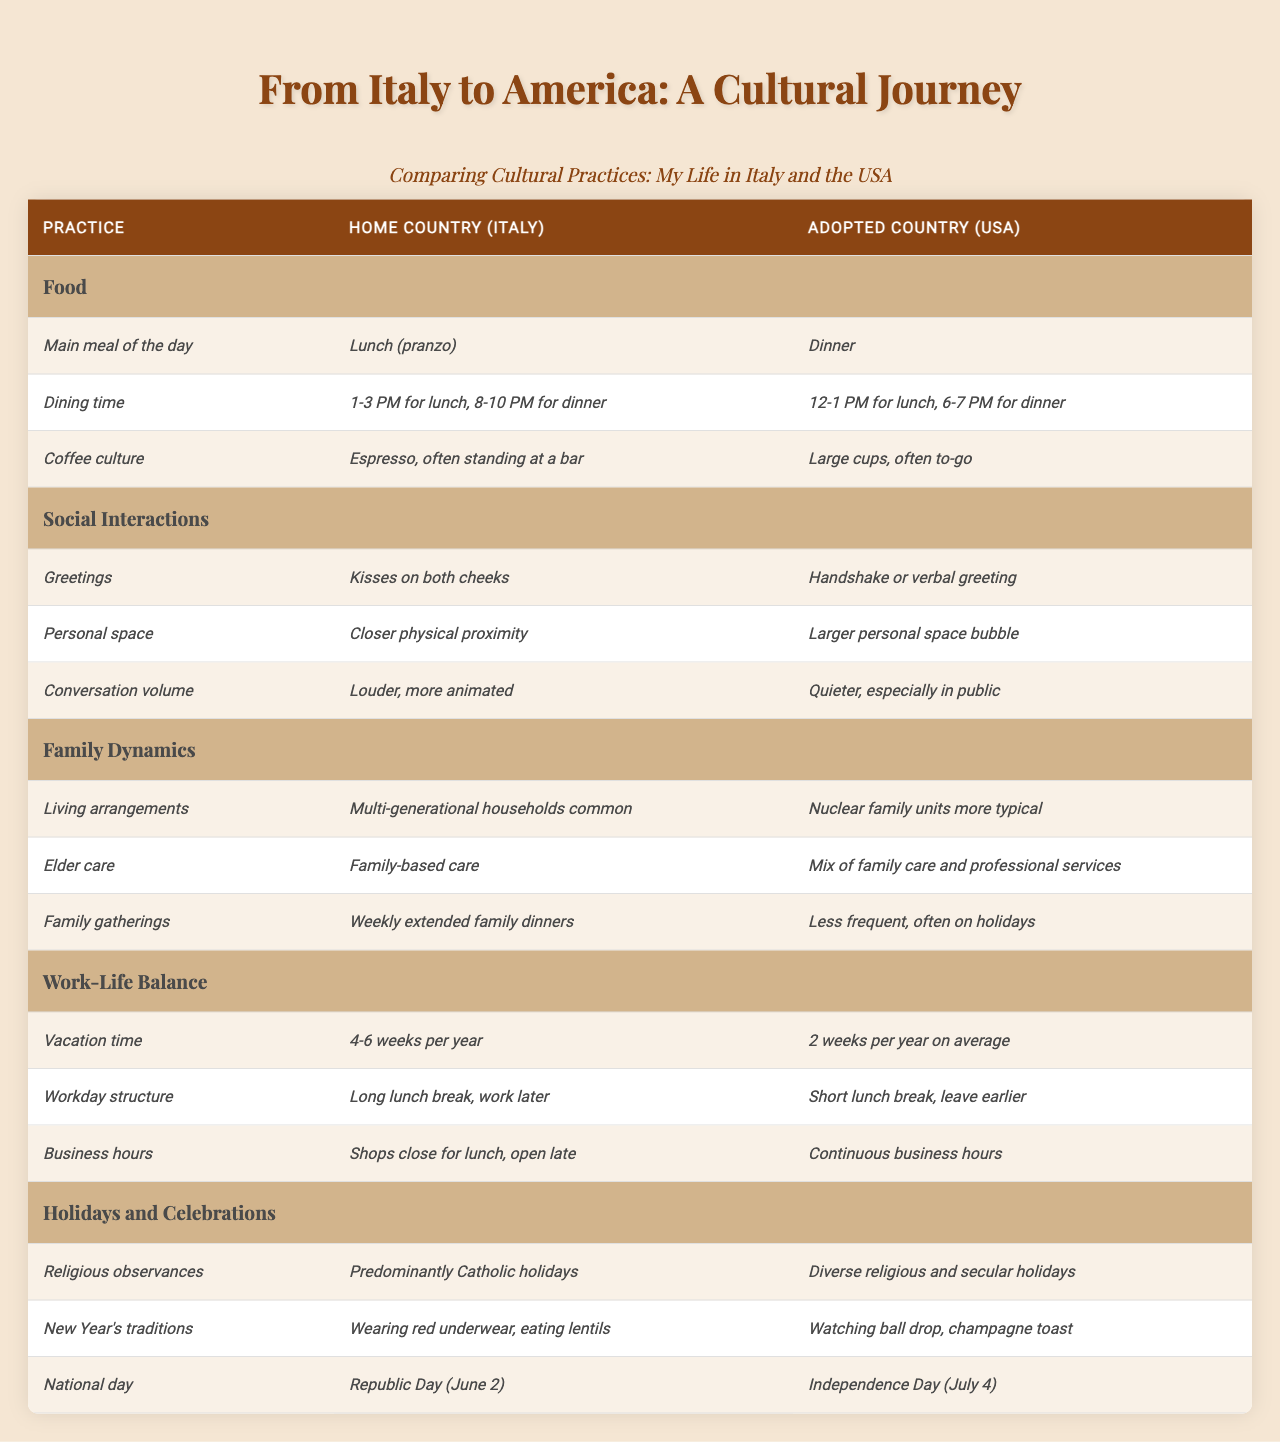What is the main meal of the day in Italy? The table indicates that in Italy, the main meal of the day is lunch (pranzo). Therefore, the information can be directly retrieved from the "Food" category under the "Main meal of the day" practice.
Answer: Lunch (pranzo) How often do families in Italy have extended family dinners compared to the USA? According to the table, Italian families have weekly extended family dinners, while such gatherings are less frequent in the USA and often occur only during holidays. This provides a clear contrast in family gathering frequency.
Answer: Weekly in Italy vs. Less frequent in the USA What is the dining time for lunch in the USA? The table specifies that in the USA, the dining time for lunch is between 12-1 PM. This is straightforwardly mentioned under the "Dining time" practice in the "Food" category.
Answer: 12-1 PM Is the coffee culture in Italy characterized by large cups and to-go options? No, the table indicates that in Italy, the coffee culture is focused on espresso, often enjoyed standing at a bar, which is different from the large cups and to-go options prevalent in the USA.
Answer: No What is the difference in vacation time between Italy and the USA? The table shows that Italians typically enjoy 4-6 weeks of vacation per year, while Americans average only 2 weeks per year. To find the difference, one would calculate the range of vacation weeks: 4 to 6 weeks in Italy compared to 2 weeks in the USA. The difference is significant.
Answer: 2-4 weeks How do greetings differ between Italy and the USA? According to the table, in Italy, greetings involve kisses on both cheeks, whereas in the USA, greetings are typically a handshake or a verbal greeting. This provides a clear distinction between the two cultures regarding greeting conventions.
Answer: Kisses in Italy vs. Handshake in the USA Which country has a higher emphasis on multi-generational households? The table suggests that Italy has a higher emphasis on multi-generational households as it states that such living arrangements are common there, while in the USA, nuclear family units are more typical. This provides insight into family dynamics in both cultures.
Answer: Italy Can we conclude that Italian holidays are predominantly religious compared to the USA? Yes, the table indicates that Italy predominantly observes Catholic holidays, whereas the USA has a diverse range of religious and secular holidays. This suggests that religious observance is more pronounced in Italy's holiday practices.
Answer: Yes What is the average duration of a vacation in Italy based on the given range? Based on the information, Italians take 4-6 weeks of vacation per year. To find the average, we calculate (4 + 6) / 2 = 5 weeks. This showcases the general vacation trend in Italy.
Answer: 5 weeks Which cultural practice has the most significant difference in terms of timing between the two countries regarding the main meal of the day? The table reflects that the main meal in Italy is lunch, typically served between 1-3 PM, while in the USA, the main meal is dinner, which occurs around 6-7 PM. The difference in timing for the main meals highlights significant cultural variation.
Answer: Lunch vs. Dinner How does the workday structure differ in Italy compared to the USA? In Italy, the workday structure includes a long lunch break with the possibility of working later, while in the USA, there is a short lunch break, and people tend to leave work earlier. Thus, the overall approach to the workday varies significantly.
Answer: Long breaks in Italy vs. Short breaks in the USA 